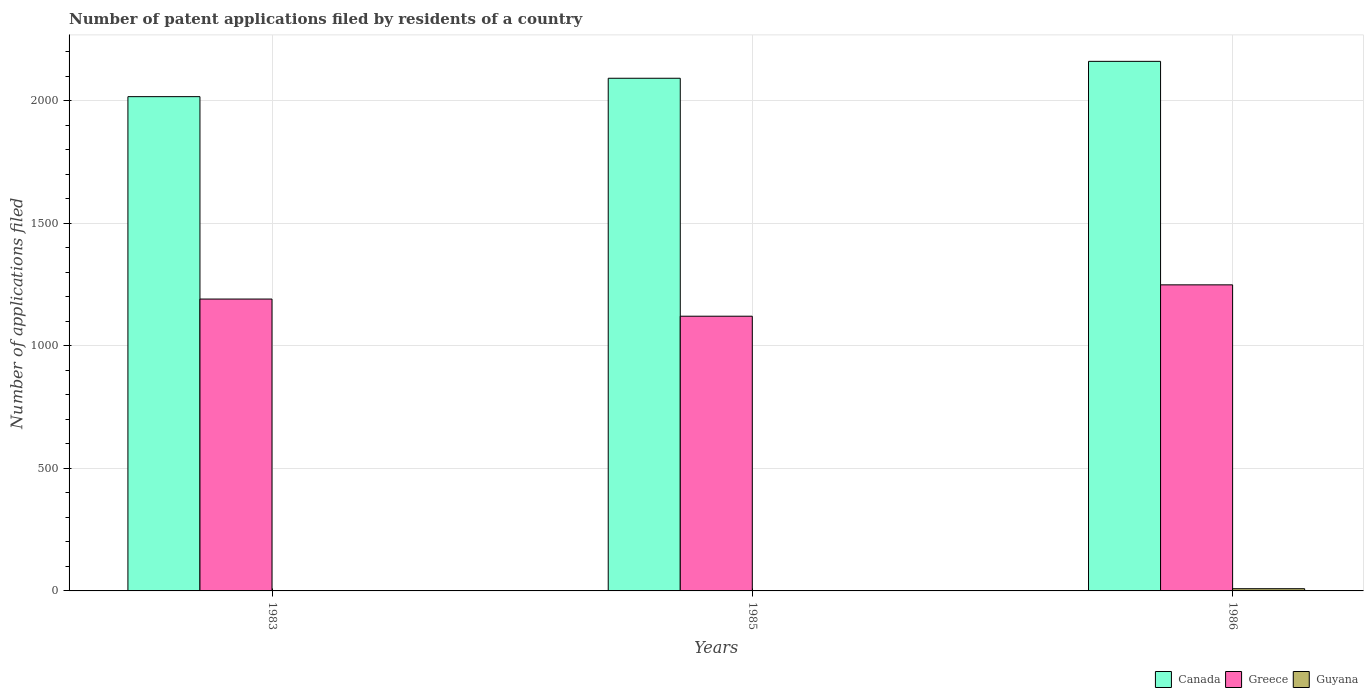How many different coloured bars are there?
Provide a succinct answer. 3. How many groups of bars are there?
Your response must be concise. 3. Are the number of bars per tick equal to the number of legend labels?
Make the answer very short. Yes. In how many cases, is the number of bars for a given year not equal to the number of legend labels?
Make the answer very short. 0. What is the number of applications filed in Canada in 1985?
Your answer should be very brief. 2092. Across all years, what is the maximum number of applications filed in Greece?
Keep it short and to the point. 1249. Across all years, what is the minimum number of applications filed in Canada?
Offer a very short reply. 2017. In which year was the number of applications filed in Canada minimum?
Offer a terse response. 1983. What is the total number of applications filed in Greece in the graph?
Offer a terse response. 3561. What is the difference between the number of applications filed in Greece in 1983 and that in 1986?
Keep it short and to the point. -58. What is the difference between the number of applications filed in Guyana in 1986 and the number of applications filed in Greece in 1983?
Make the answer very short. -1182. What is the average number of applications filed in Guyana per year?
Keep it short and to the point. 3.67. In the year 1985, what is the difference between the number of applications filed in Greece and number of applications filed in Guyana?
Ensure brevity in your answer.  1120. In how many years, is the number of applications filed in Greece greater than 1500?
Your response must be concise. 0. What is the ratio of the number of applications filed in Greece in 1983 to that in 1986?
Provide a short and direct response. 0.95. Is the number of applications filed in Greece in 1983 less than that in 1986?
Make the answer very short. Yes. Is the difference between the number of applications filed in Greece in 1983 and 1986 greater than the difference between the number of applications filed in Guyana in 1983 and 1986?
Your answer should be compact. No. What is the difference between the highest and the second highest number of applications filed in Guyana?
Make the answer very short. 8. What is the difference between the highest and the lowest number of applications filed in Canada?
Your answer should be compact. 144. Is the sum of the number of applications filed in Greece in 1983 and 1986 greater than the maximum number of applications filed in Guyana across all years?
Your response must be concise. Yes. What does the 3rd bar from the right in 1986 represents?
Offer a very short reply. Canada. How many bars are there?
Your response must be concise. 9. Does the graph contain any zero values?
Your answer should be compact. No. How many legend labels are there?
Make the answer very short. 3. How are the legend labels stacked?
Your answer should be compact. Horizontal. What is the title of the graph?
Ensure brevity in your answer.  Number of patent applications filed by residents of a country. What is the label or title of the X-axis?
Your answer should be compact. Years. What is the label or title of the Y-axis?
Offer a terse response. Number of applications filed. What is the Number of applications filed of Canada in 1983?
Your answer should be compact. 2017. What is the Number of applications filed of Greece in 1983?
Ensure brevity in your answer.  1191. What is the Number of applications filed in Guyana in 1983?
Make the answer very short. 1. What is the Number of applications filed of Canada in 1985?
Ensure brevity in your answer.  2092. What is the Number of applications filed of Greece in 1985?
Your response must be concise. 1121. What is the Number of applications filed in Guyana in 1985?
Make the answer very short. 1. What is the Number of applications filed in Canada in 1986?
Offer a very short reply. 2161. What is the Number of applications filed of Greece in 1986?
Make the answer very short. 1249. What is the Number of applications filed in Guyana in 1986?
Offer a terse response. 9. Across all years, what is the maximum Number of applications filed of Canada?
Make the answer very short. 2161. Across all years, what is the maximum Number of applications filed of Greece?
Give a very brief answer. 1249. Across all years, what is the minimum Number of applications filed in Canada?
Your response must be concise. 2017. Across all years, what is the minimum Number of applications filed of Greece?
Give a very brief answer. 1121. Across all years, what is the minimum Number of applications filed of Guyana?
Ensure brevity in your answer.  1. What is the total Number of applications filed in Canada in the graph?
Provide a succinct answer. 6270. What is the total Number of applications filed of Greece in the graph?
Provide a short and direct response. 3561. What is the total Number of applications filed of Guyana in the graph?
Your answer should be compact. 11. What is the difference between the Number of applications filed of Canada in 1983 and that in 1985?
Your response must be concise. -75. What is the difference between the Number of applications filed in Canada in 1983 and that in 1986?
Provide a succinct answer. -144. What is the difference between the Number of applications filed of Greece in 1983 and that in 1986?
Your response must be concise. -58. What is the difference between the Number of applications filed of Guyana in 1983 and that in 1986?
Keep it short and to the point. -8. What is the difference between the Number of applications filed in Canada in 1985 and that in 1986?
Provide a short and direct response. -69. What is the difference between the Number of applications filed of Greece in 1985 and that in 1986?
Your answer should be compact. -128. What is the difference between the Number of applications filed in Canada in 1983 and the Number of applications filed in Greece in 1985?
Ensure brevity in your answer.  896. What is the difference between the Number of applications filed of Canada in 1983 and the Number of applications filed of Guyana in 1985?
Your answer should be very brief. 2016. What is the difference between the Number of applications filed in Greece in 1983 and the Number of applications filed in Guyana in 1985?
Provide a short and direct response. 1190. What is the difference between the Number of applications filed of Canada in 1983 and the Number of applications filed of Greece in 1986?
Provide a succinct answer. 768. What is the difference between the Number of applications filed in Canada in 1983 and the Number of applications filed in Guyana in 1986?
Provide a short and direct response. 2008. What is the difference between the Number of applications filed in Greece in 1983 and the Number of applications filed in Guyana in 1986?
Ensure brevity in your answer.  1182. What is the difference between the Number of applications filed in Canada in 1985 and the Number of applications filed in Greece in 1986?
Your answer should be very brief. 843. What is the difference between the Number of applications filed in Canada in 1985 and the Number of applications filed in Guyana in 1986?
Ensure brevity in your answer.  2083. What is the difference between the Number of applications filed in Greece in 1985 and the Number of applications filed in Guyana in 1986?
Your answer should be very brief. 1112. What is the average Number of applications filed in Canada per year?
Your response must be concise. 2090. What is the average Number of applications filed in Greece per year?
Your response must be concise. 1187. What is the average Number of applications filed of Guyana per year?
Ensure brevity in your answer.  3.67. In the year 1983, what is the difference between the Number of applications filed of Canada and Number of applications filed of Greece?
Your answer should be compact. 826. In the year 1983, what is the difference between the Number of applications filed in Canada and Number of applications filed in Guyana?
Ensure brevity in your answer.  2016. In the year 1983, what is the difference between the Number of applications filed of Greece and Number of applications filed of Guyana?
Your response must be concise. 1190. In the year 1985, what is the difference between the Number of applications filed in Canada and Number of applications filed in Greece?
Keep it short and to the point. 971. In the year 1985, what is the difference between the Number of applications filed in Canada and Number of applications filed in Guyana?
Your answer should be compact. 2091. In the year 1985, what is the difference between the Number of applications filed in Greece and Number of applications filed in Guyana?
Make the answer very short. 1120. In the year 1986, what is the difference between the Number of applications filed in Canada and Number of applications filed in Greece?
Your answer should be compact. 912. In the year 1986, what is the difference between the Number of applications filed of Canada and Number of applications filed of Guyana?
Offer a very short reply. 2152. In the year 1986, what is the difference between the Number of applications filed of Greece and Number of applications filed of Guyana?
Your answer should be very brief. 1240. What is the ratio of the Number of applications filed in Canada in 1983 to that in 1985?
Your answer should be compact. 0.96. What is the ratio of the Number of applications filed in Greece in 1983 to that in 1985?
Your answer should be very brief. 1.06. What is the ratio of the Number of applications filed in Canada in 1983 to that in 1986?
Ensure brevity in your answer.  0.93. What is the ratio of the Number of applications filed of Greece in 1983 to that in 1986?
Keep it short and to the point. 0.95. What is the ratio of the Number of applications filed of Guyana in 1983 to that in 1986?
Offer a very short reply. 0.11. What is the ratio of the Number of applications filed in Canada in 1985 to that in 1986?
Offer a terse response. 0.97. What is the ratio of the Number of applications filed in Greece in 1985 to that in 1986?
Make the answer very short. 0.9. What is the ratio of the Number of applications filed in Guyana in 1985 to that in 1986?
Your response must be concise. 0.11. What is the difference between the highest and the second highest Number of applications filed of Greece?
Offer a very short reply. 58. What is the difference between the highest and the lowest Number of applications filed in Canada?
Your response must be concise. 144. What is the difference between the highest and the lowest Number of applications filed of Greece?
Provide a succinct answer. 128. 